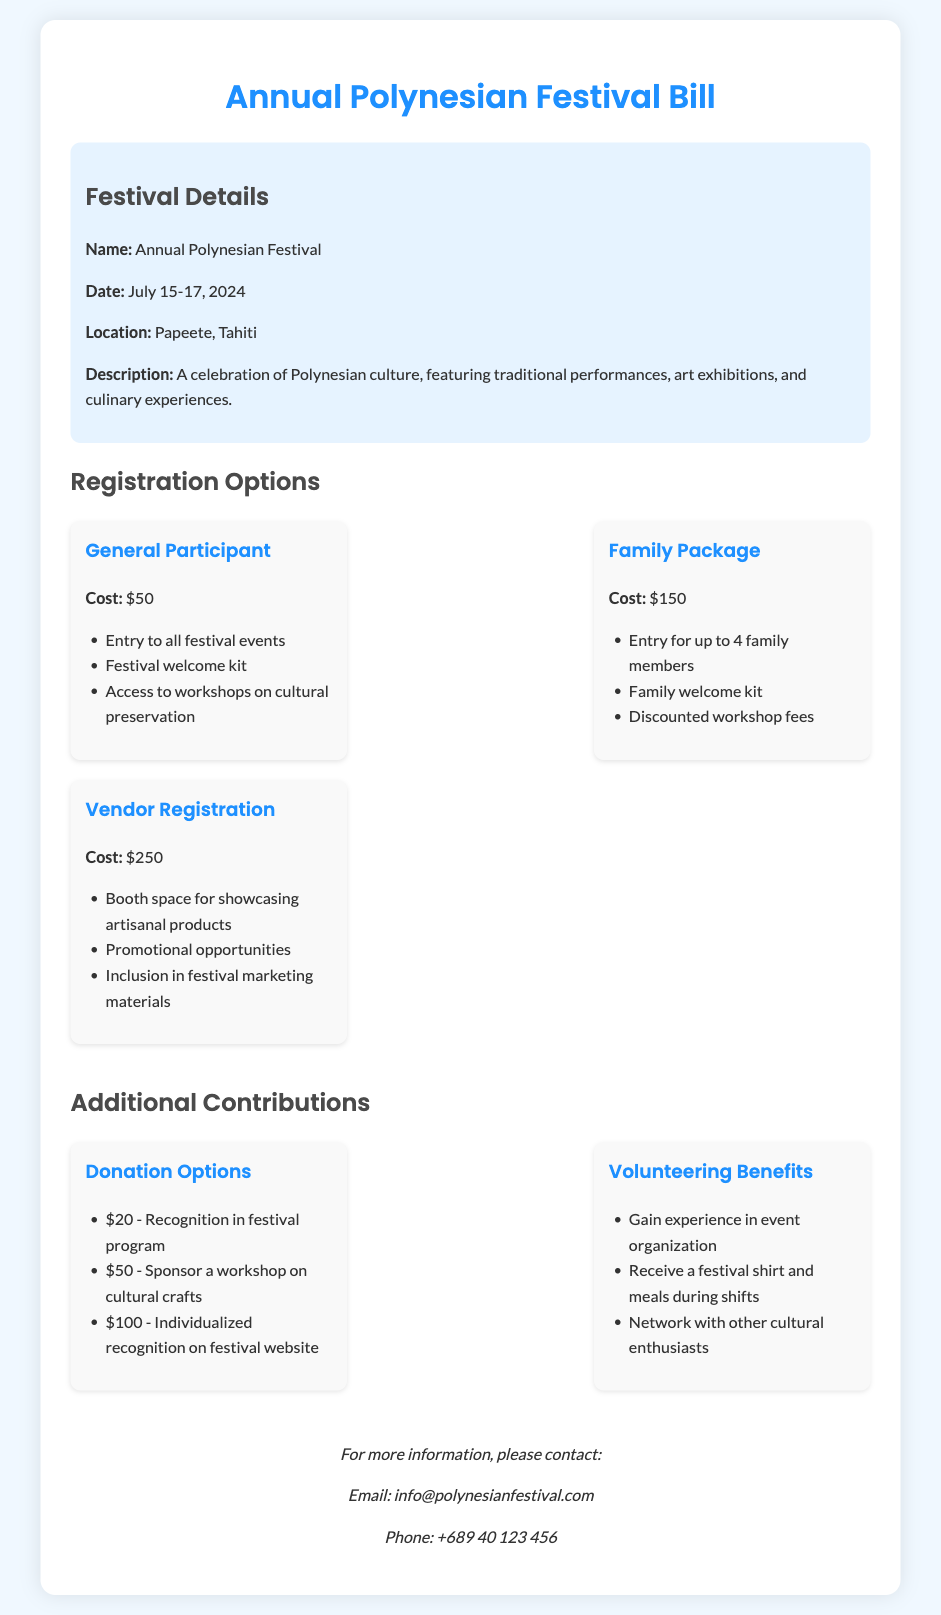what is the date of the festival? The date of the festival is mentioned in the document as July 15-17, 2024.
Answer: July 15-17, 2024 how much does the Family Package cost? The Family Package cost is listed in the document.
Answer: $150 what is included for General Participants? The document outlines the benefits for General Participants, which includes entry to all events, welcome kit, and access to workshops.
Answer: Entry to all festival events, Festival welcome kit, Access to workshops on cultural preservation how many family members can attend with the Family Package? The Family Package allows entry for up to 4 family members as stated in the document.
Answer: Up to 4 family members what is one of the volunteering benefits? The document provides benefits for volunteers, including gaining experience in event organization.
Answer: Gain experience in event organization how much is the fee for Vendor Registration? The fee for Vendor Registration is specified in the document.
Answer: $250 what recognition will a $20 donation receive? The document states that a $20 donation will result in recognition in the festival program.
Answer: Recognition in festival program what is the location of the festival? The location of the festival is mentioned in the document as Papeete, Tahiti.
Answer: Papeete, Tahiti what promotional opportunities are included in the Vendor Registration? The document lists promotional opportunities as part of the Vendor Registration benefits.
Answer: Promotional opportunities 